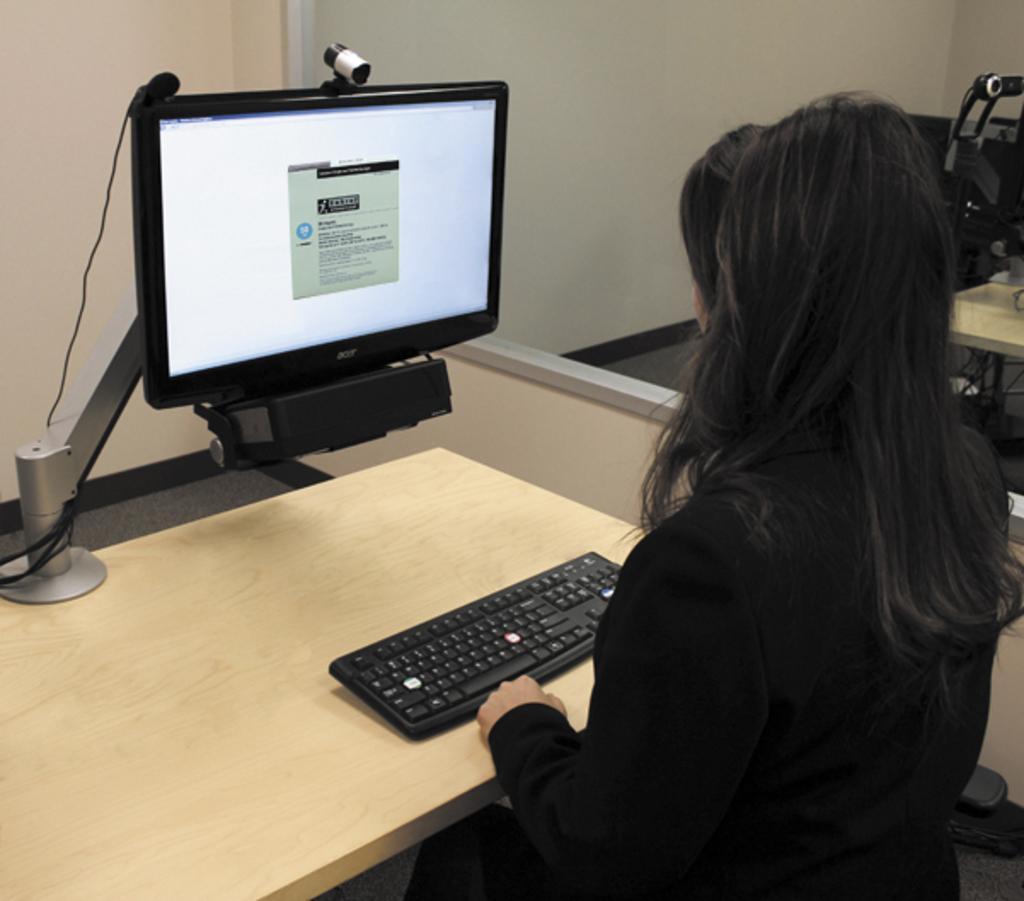Could you give a brief overview of what you see in this image? In this image there is a computer , keyboard in the table and a woman sitting in a chair. 